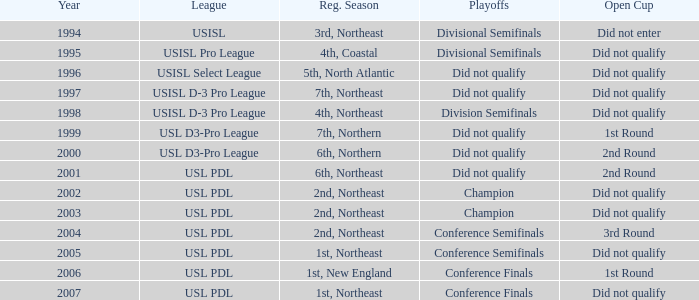Name the total number of years for usisl pro league 1.0. 